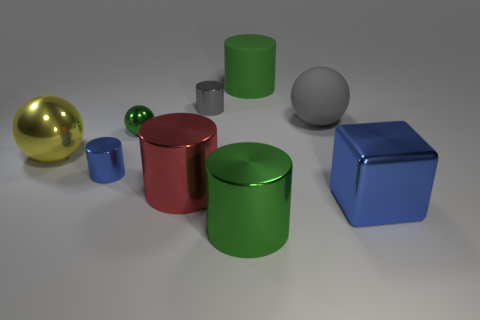What is the gray ball made of?
Provide a succinct answer. Rubber. Are the green cylinder that is in front of the big red metal cylinder and the big thing that is to the right of the gray rubber ball made of the same material?
Offer a very short reply. Yes. Is there any other thing that has the same color as the big metal sphere?
Your answer should be compact. No. The large rubber thing that is the same shape as the small gray metal thing is what color?
Make the answer very short. Green. There is a green object that is both behind the blue metallic cylinder and to the right of the big red metallic thing; how big is it?
Ensure brevity in your answer.  Large. Does the big gray rubber thing to the right of the tiny green shiny thing have the same shape as the green shiny thing that is behind the big yellow ball?
Provide a short and direct response. Yes. There is a small shiny thing that is the same color as the big rubber cylinder; what shape is it?
Provide a succinct answer. Sphere. How many large red spheres have the same material as the tiny blue cylinder?
Offer a terse response. 0. There is a thing that is both behind the large gray thing and on the left side of the large green rubber cylinder; what shape is it?
Your answer should be very brief. Cylinder. Is the big green thing that is in front of the large yellow shiny ball made of the same material as the gray ball?
Keep it short and to the point. No. 